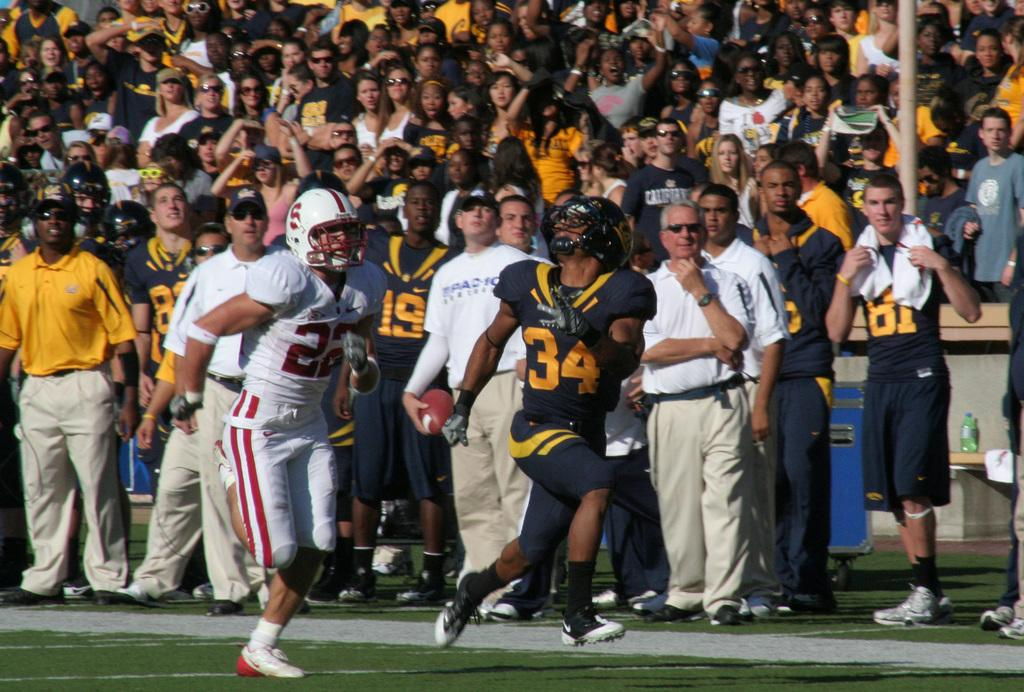How many people are in the image? There are 2 persons in the image. What are the persons wearing? The persons are wearing jerseys and helmets. Where are the persons located? The persons are on the grass. Can you describe the background of the image? There are people in the background of the image. What type of government is depicted in the image? There is no depiction of a government in the image; it features 2 persons wearing jerseys and helmets on the grass. How are the persons transporting themselves in the image? The persons are not shown transporting themselves in the image; they are stationary on the grass. 